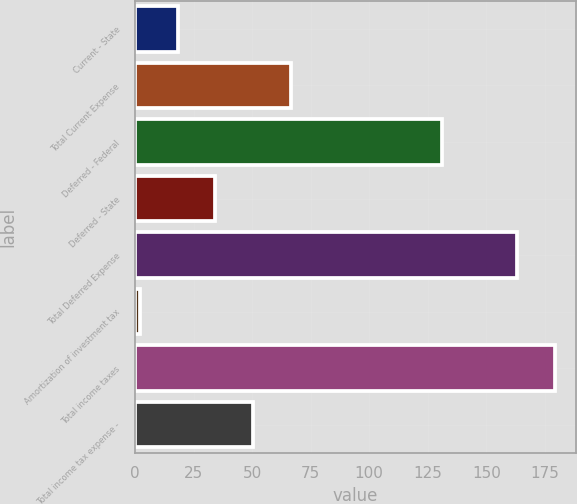Convert chart. <chart><loc_0><loc_0><loc_500><loc_500><bar_chart><fcel>Current - State<fcel>Total Current Expense<fcel>Deferred - Federal<fcel>Deferred - State<fcel>Total Deferred Expense<fcel>Amortization of investment tax<fcel>Total income taxes<fcel>Total income tax expense -<nl><fcel>18.1<fcel>66.4<fcel>131<fcel>34.2<fcel>163.2<fcel>2<fcel>179.3<fcel>50.3<nl></chart> 